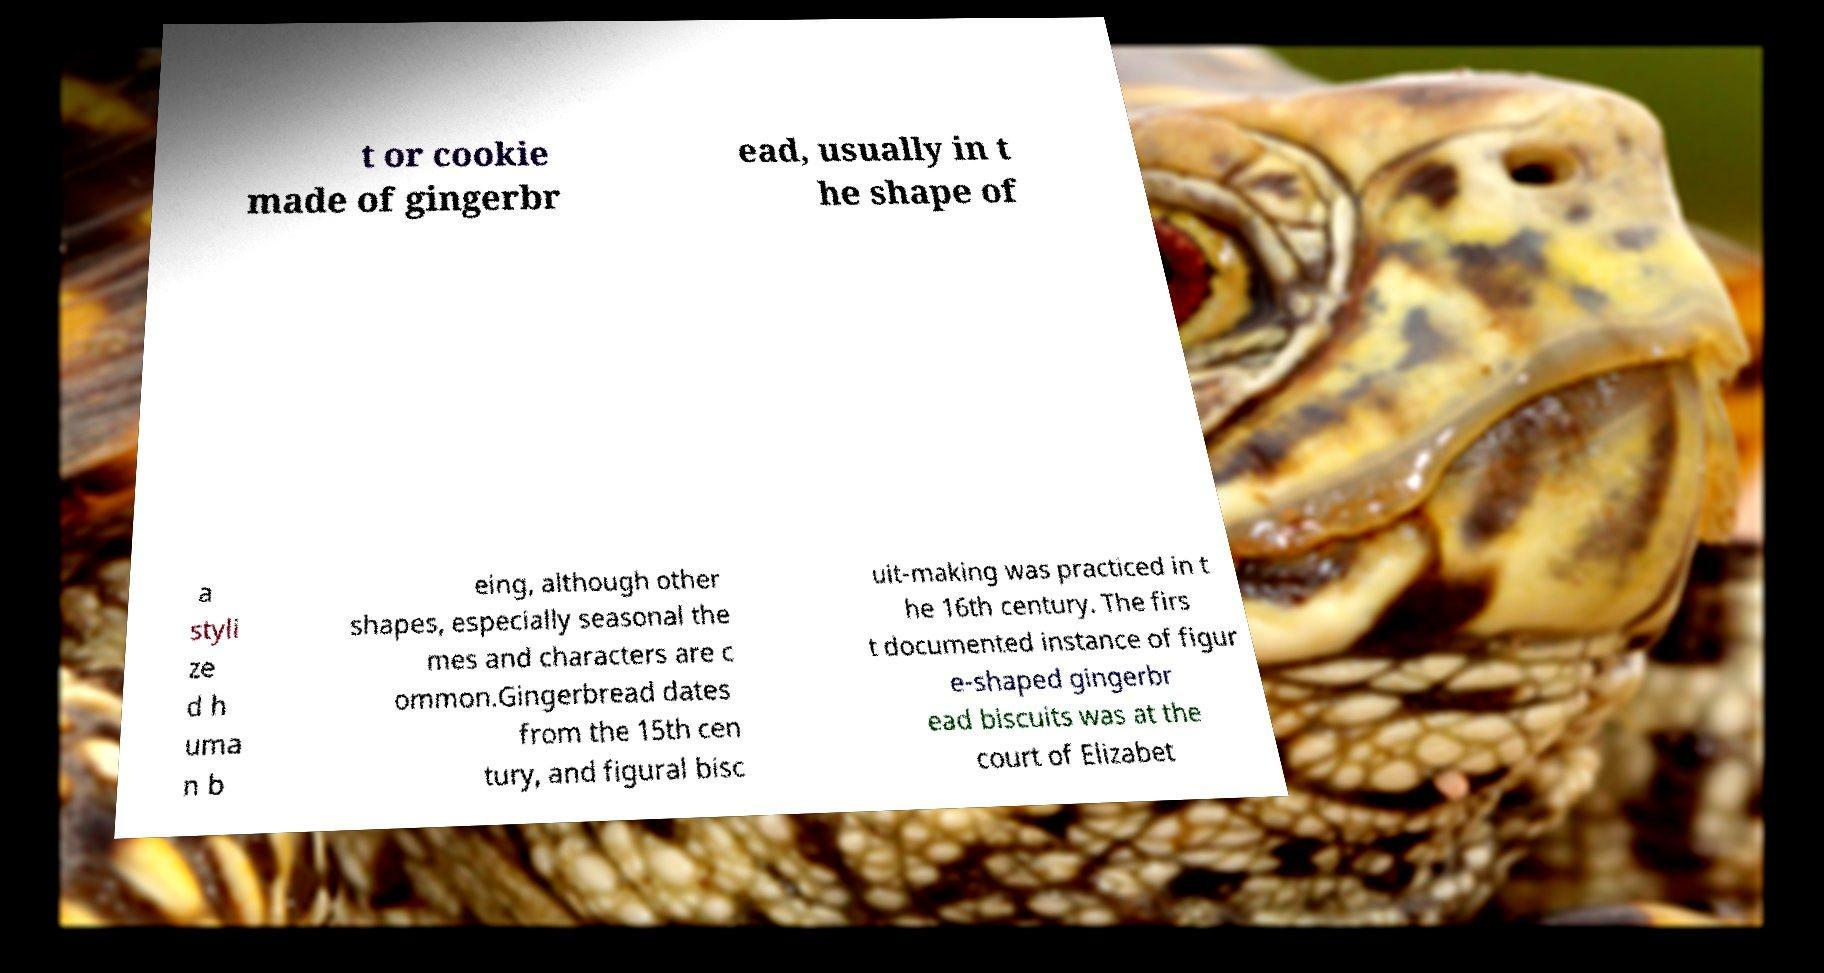There's text embedded in this image that I need extracted. Can you transcribe it verbatim? t or cookie made of gingerbr ead, usually in t he shape of a styli ze d h uma n b eing, although other shapes, especially seasonal the mes and characters are c ommon.Gingerbread dates from the 15th cen tury, and figural bisc uit-making was practiced in t he 16th century. The firs t documented instance of figur e-shaped gingerbr ead biscuits was at the court of Elizabet 